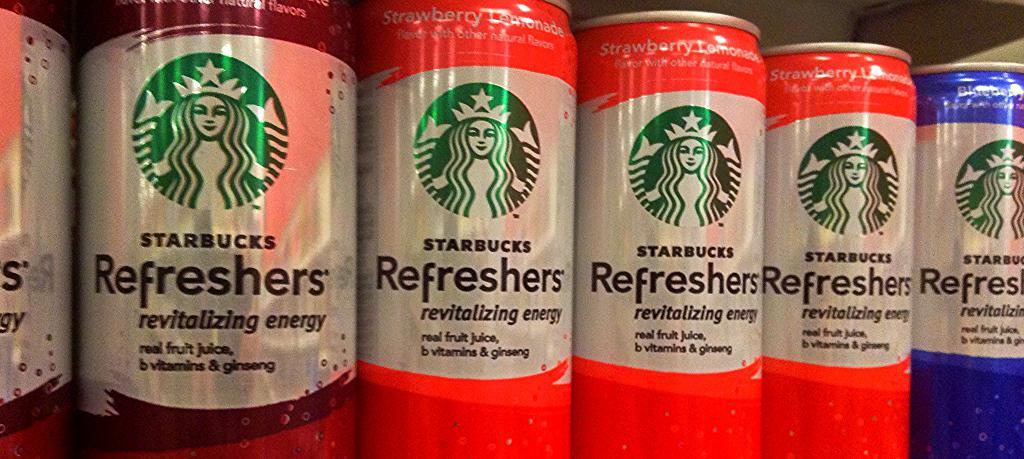Provide a one-sentence caption for the provided image. several cans of drinks with the words starbucks refreshers on them. 